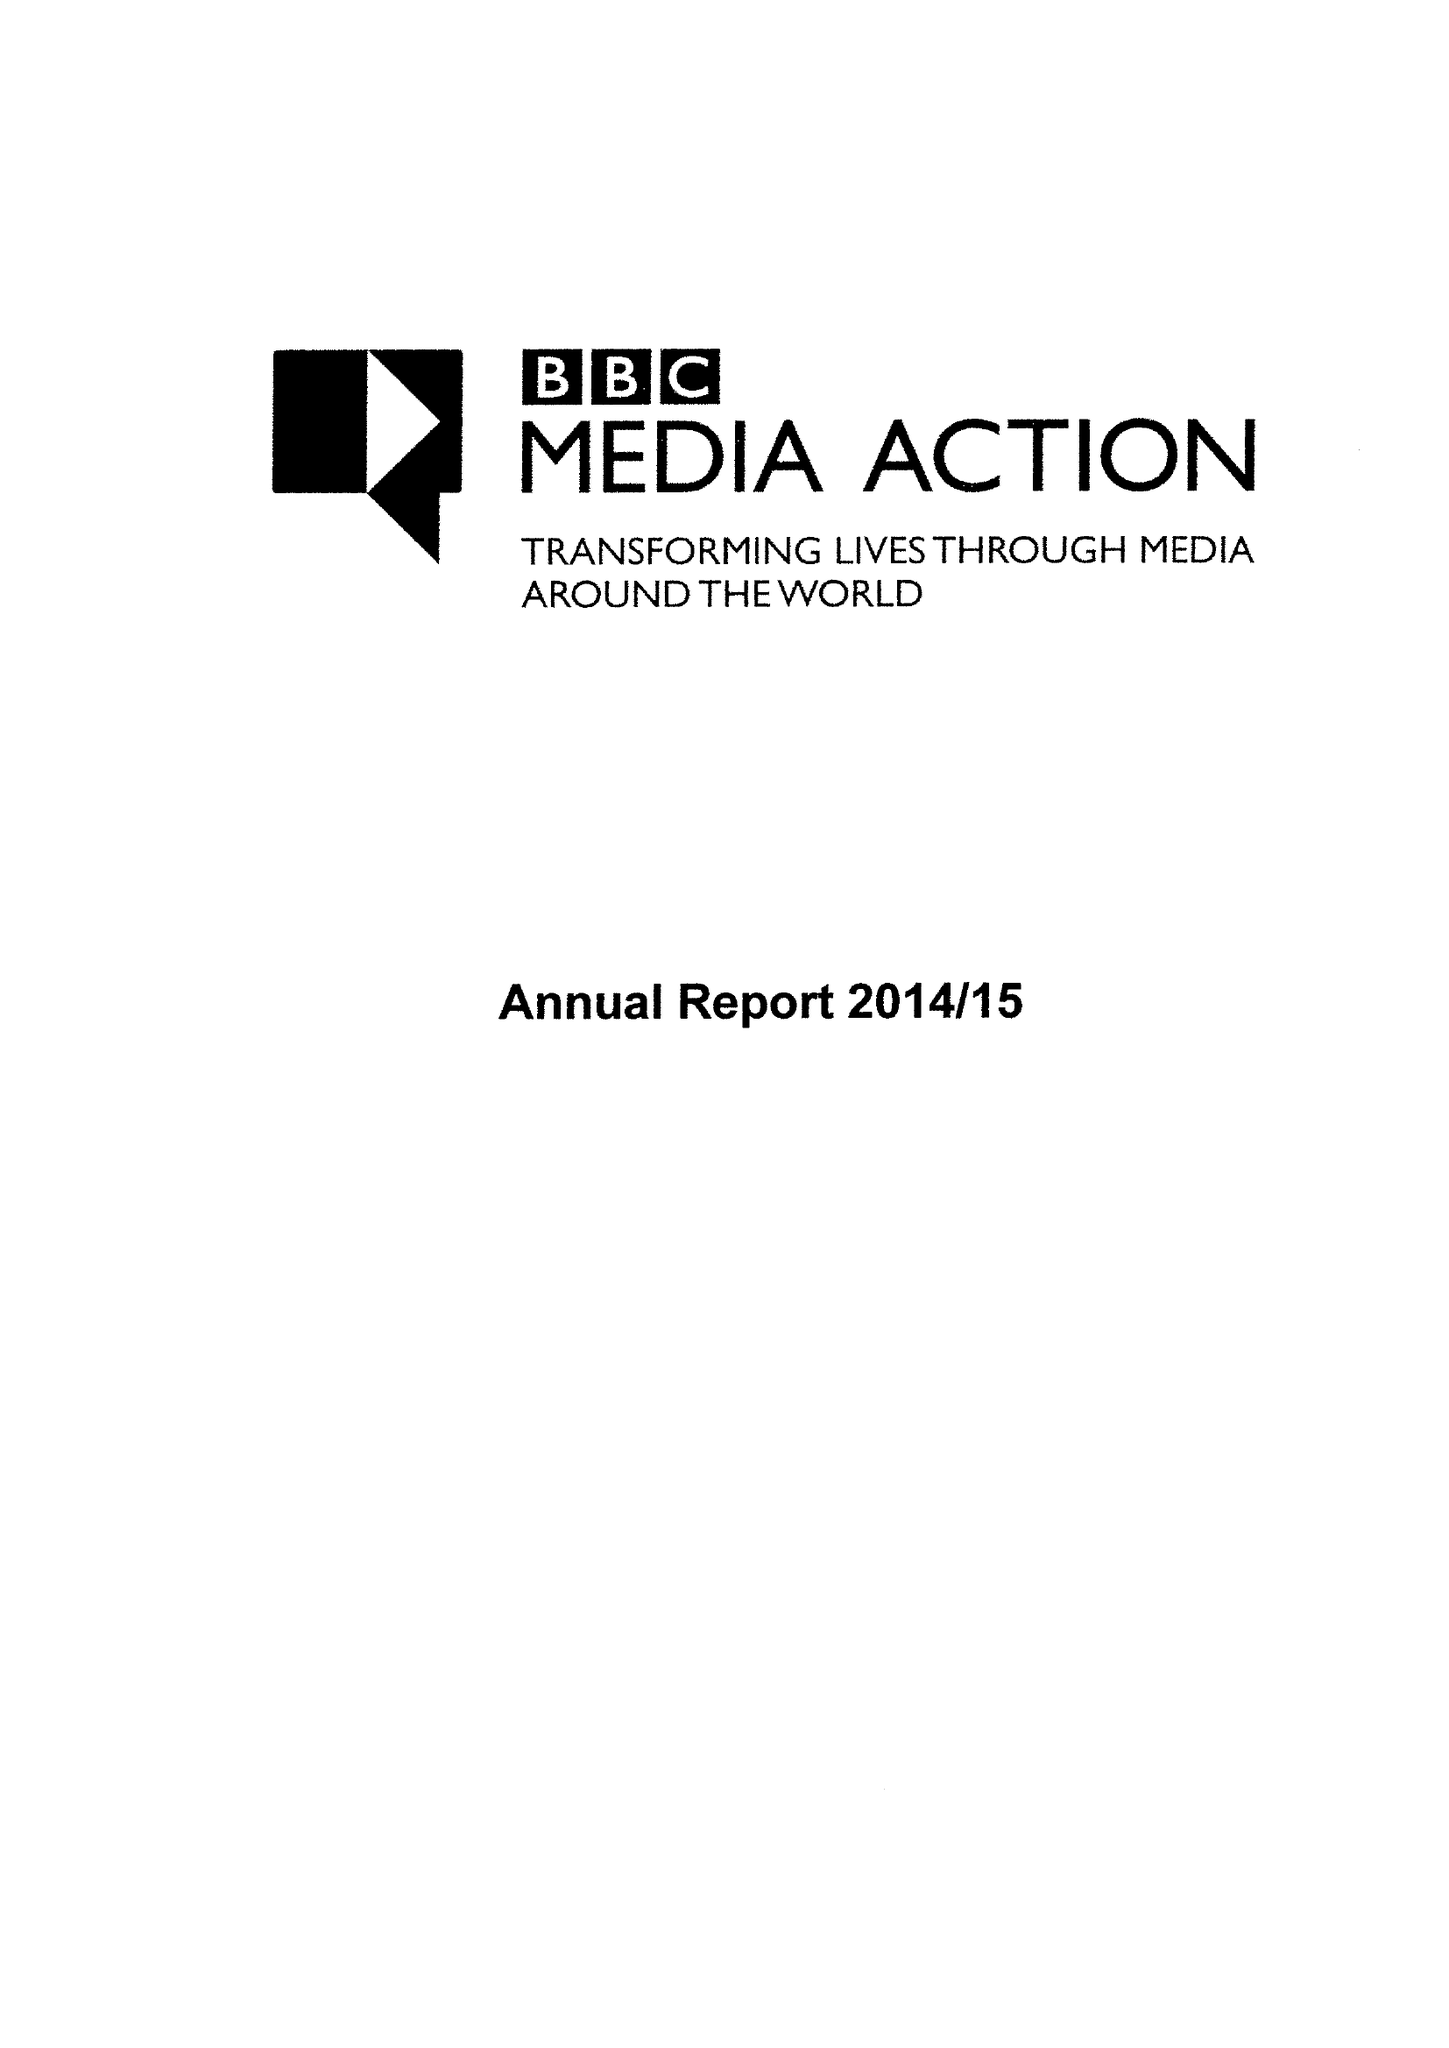What is the value for the charity_name?
Answer the question using a single word or phrase. Bbc Media Action 